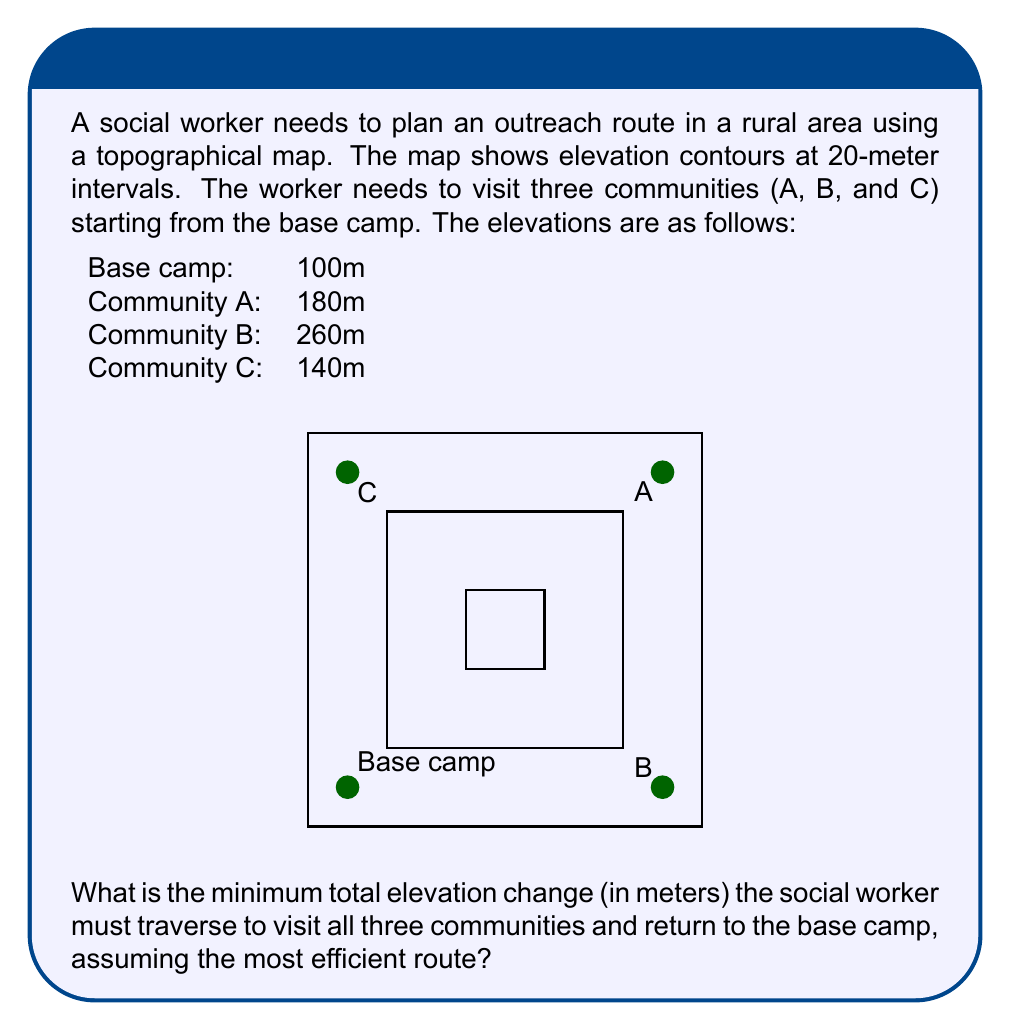Help me with this question. To solve this problem, we need to determine the most efficient route that minimizes the total elevation change. Let's approach this step-by-step:

1) First, let's calculate the elevation differences between each location:
   - Base camp to A: $180m - 100m = 80m$
   - A to B: $260m - 180m = 80m$
   - B to C: $260m - 140m = 120m$
   - C to Base camp: $140m - 100m = 40m$

2) The most efficient route will be the one that avoids climbing the same elevation twice. In this case, the optimal route is:

   Base camp → A → B → C → Base camp

3) Let's calculate the total elevation change for this route:
   - Base camp to A: $80m$ (ascending)
   - A to B: $80m$ (ascending)
   - B to C: $120m$ (descending)
   - C to Base camp: $40m$ (descending)

4) The total elevation change is the sum of all these changes, regardless of whether they're ascending or descending:

   $$80m + 80m + 120m + 40m = 320m$$

Therefore, the minimum total elevation change the social worker must traverse is 320 meters.
Answer: 320 meters 